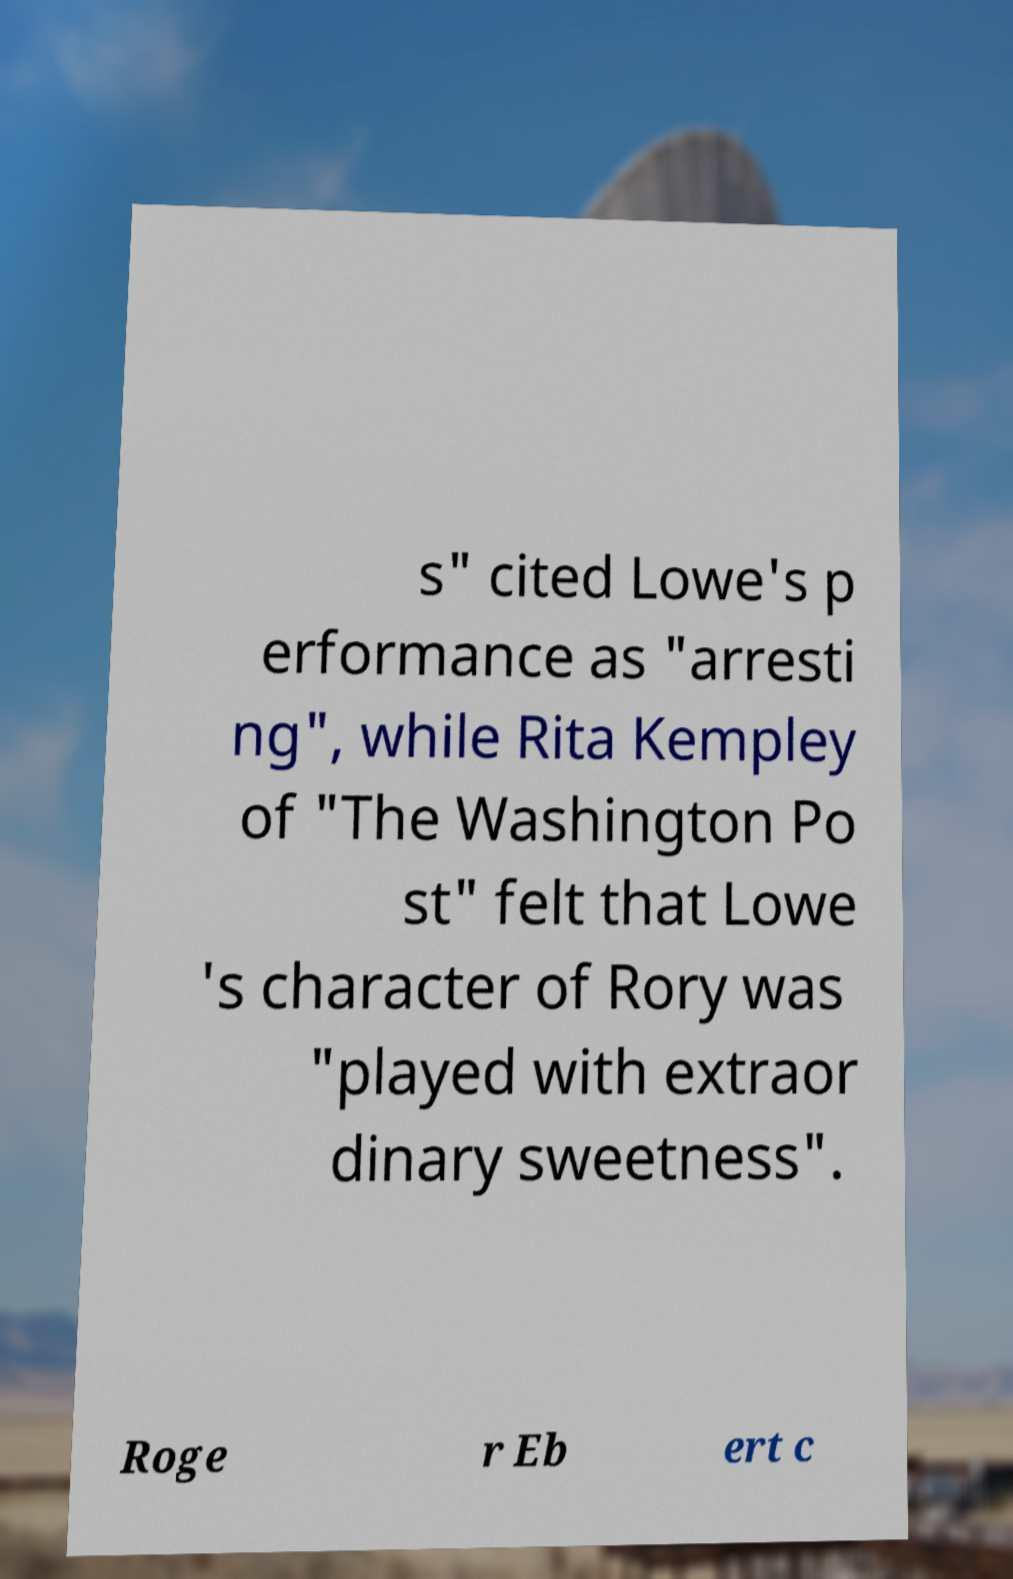Can you read and provide the text displayed in the image?This photo seems to have some interesting text. Can you extract and type it out for me? s" cited Lowe's p erformance as "arresti ng", while Rita Kempley of "The Washington Po st" felt that Lowe 's character of Rory was "played with extraor dinary sweetness". Roge r Eb ert c 